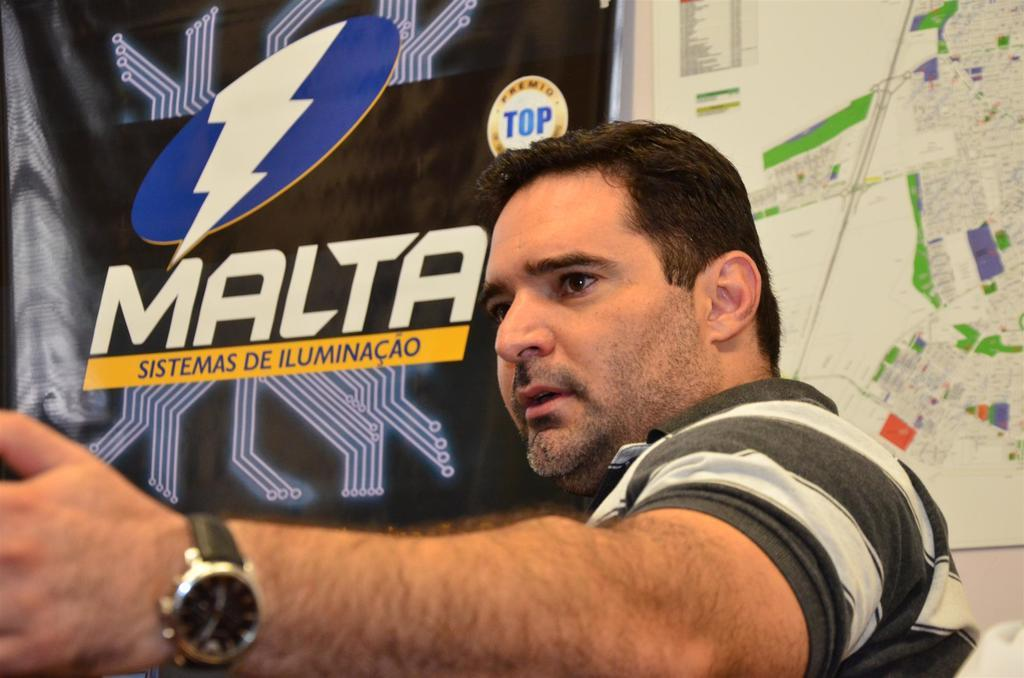<image>
Relay a brief, clear account of the picture shown. A man wearing a watch with a sign about Malta behind him. 